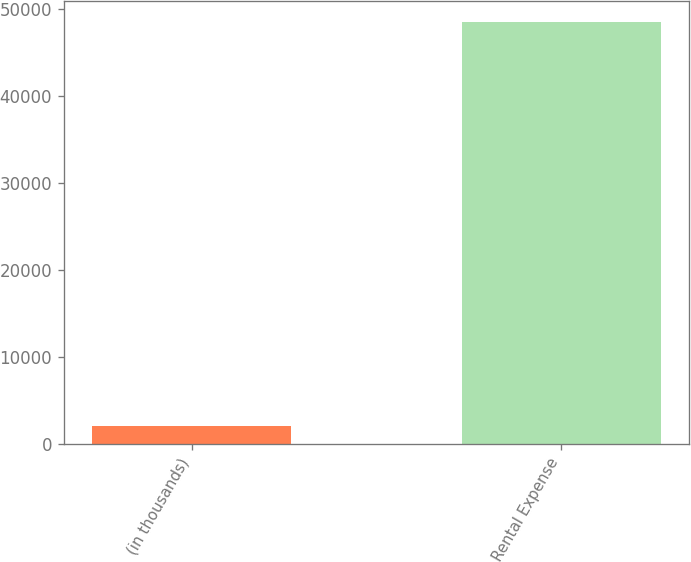Convert chart. <chart><loc_0><loc_0><loc_500><loc_500><bar_chart><fcel>(in thousands)<fcel>Rental Expense<nl><fcel>2012<fcel>48511<nl></chart> 